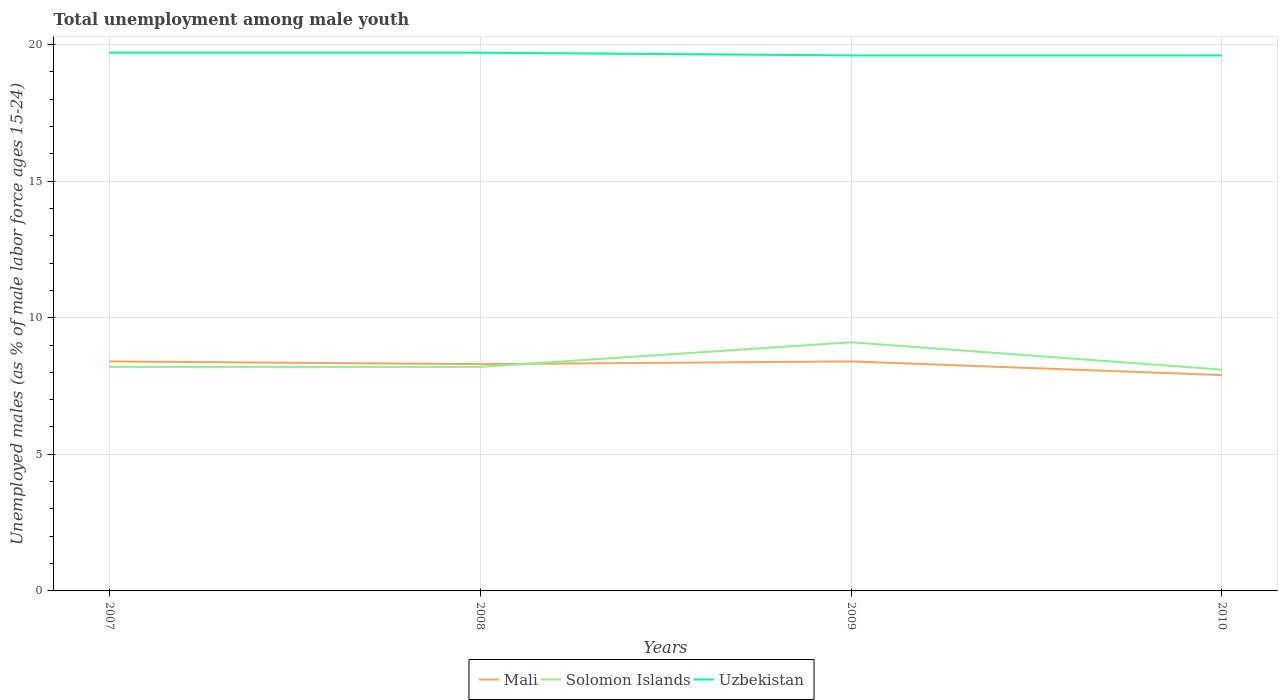Is the number of lines equal to the number of legend labels?
Give a very brief answer. Yes. Across all years, what is the maximum percentage of unemployed males in in Uzbekistan?
Ensure brevity in your answer.  19.6. What is the difference between the highest and the second highest percentage of unemployed males in in Mali?
Provide a short and direct response. 0.5. Is the percentage of unemployed males in in Uzbekistan strictly greater than the percentage of unemployed males in in Solomon Islands over the years?
Ensure brevity in your answer.  No. How many lines are there?
Offer a very short reply. 3. How many years are there in the graph?
Give a very brief answer. 4. Are the values on the major ticks of Y-axis written in scientific E-notation?
Offer a very short reply. No. Does the graph contain grids?
Your response must be concise. Yes. Where does the legend appear in the graph?
Keep it short and to the point. Bottom center. How many legend labels are there?
Provide a succinct answer. 3. What is the title of the graph?
Your answer should be compact. Total unemployment among male youth. What is the label or title of the Y-axis?
Offer a very short reply. Unemployed males (as % of male labor force ages 15-24). What is the Unemployed males (as % of male labor force ages 15-24) in Mali in 2007?
Provide a short and direct response. 8.4. What is the Unemployed males (as % of male labor force ages 15-24) in Solomon Islands in 2007?
Ensure brevity in your answer.  8.2. What is the Unemployed males (as % of male labor force ages 15-24) in Uzbekistan in 2007?
Provide a succinct answer. 19.7. What is the Unemployed males (as % of male labor force ages 15-24) of Mali in 2008?
Your response must be concise. 8.3. What is the Unemployed males (as % of male labor force ages 15-24) of Solomon Islands in 2008?
Your answer should be compact. 8.2. What is the Unemployed males (as % of male labor force ages 15-24) of Uzbekistan in 2008?
Provide a succinct answer. 19.7. What is the Unemployed males (as % of male labor force ages 15-24) in Mali in 2009?
Offer a very short reply. 8.4. What is the Unemployed males (as % of male labor force ages 15-24) in Solomon Islands in 2009?
Your answer should be compact. 9.1. What is the Unemployed males (as % of male labor force ages 15-24) of Uzbekistan in 2009?
Your answer should be compact. 19.6. What is the Unemployed males (as % of male labor force ages 15-24) in Mali in 2010?
Your answer should be very brief. 7.9. What is the Unemployed males (as % of male labor force ages 15-24) in Solomon Islands in 2010?
Ensure brevity in your answer.  8.1. What is the Unemployed males (as % of male labor force ages 15-24) in Uzbekistan in 2010?
Your answer should be very brief. 19.6. Across all years, what is the maximum Unemployed males (as % of male labor force ages 15-24) in Mali?
Your response must be concise. 8.4. Across all years, what is the maximum Unemployed males (as % of male labor force ages 15-24) of Solomon Islands?
Ensure brevity in your answer.  9.1. Across all years, what is the maximum Unemployed males (as % of male labor force ages 15-24) of Uzbekistan?
Your response must be concise. 19.7. Across all years, what is the minimum Unemployed males (as % of male labor force ages 15-24) of Mali?
Your answer should be compact. 7.9. Across all years, what is the minimum Unemployed males (as % of male labor force ages 15-24) of Solomon Islands?
Ensure brevity in your answer.  8.1. Across all years, what is the minimum Unemployed males (as % of male labor force ages 15-24) in Uzbekistan?
Make the answer very short. 19.6. What is the total Unemployed males (as % of male labor force ages 15-24) in Solomon Islands in the graph?
Ensure brevity in your answer.  33.6. What is the total Unemployed males (as % of male labor force ages 15-24) in Uzbekistan in the graph?
Offer a very short reply. 78.6. What is the difference between the Unemployed males (as % of male labor force ages 15-24) of Mali in 2007 and that in 2009?
Your response must be concise. 0. What is the difference between the Unemployed males (as % of male labor force ages 15-24) in Solomon Islands in 2007 and that in 2009?
Give a very brief answer. -0.9. What is the difference between the Unemployed males (as % of male labor force ages 15-24) in Uzbekistan in 2007 and that in 2009?
Give a very brief answer. 0.1. What is the difference between the Unemployed males (as % of male labor force ages 15-24) in Mali in 2008 and that in 2009?
Your answer should be compact. -0.1. What is the difference between the Unemployed males (as % of male labor force ages 15-24) in Mali in 2008 and that in 2010?
Your answer should be compact. 0.4. What is the difference between the Unemployed males (as % of male labor force ages 15-24) in Uzbekistan in 2008 and that in 2010?
Offer a very short reply. 0.1. What is the difference between the Unemployed males (as % of male labor force ages 15-24) of Mali in 2009 and that in 2010?
Give a very brief answer. 0.5. What is the difference between the Unemployed males (as % of male labor force ages 15-24) in Solomon Islands in 2009 and that in 2010?
Keep it short and to the point. 1. What is the difference between the Unemployed males (as % of male labor force ages 15-24) of Solomon Islands in 2007 and the Unemployed males (as % of male labor force ages 15-24) of Uzbekistan in 2008?
Give a very brief answer. -11.5. What is the difference between the Unemployed males (as % of male labor force ages 15-24) in Mali in 2007 and the Unemployed males (as % of male labor force ages 15-24) in Uzbekistan in 2009?
Your response must be concise. -11.2. What is the difference between the Unemployed males (as % of male labor force ages 15-24) in Solomon Islands in 2007 and the Unemployed males (as % of male labor force ages 15-24) in Uzbekistan in 2009?
Ensure brevity in your answer.  -11.4. What is the difference between the Unemployed males (as % of male labor force ages 15-24) in Mali in 2007 and the Unemployed males (as % of male labor force ages 15-24) in Solomon Islands in 2010?
Your answer should be very brief. 0.3. What is the difference between the Unemployed males (as % of male labor force ages 15-24) in Mali in 2008 and the Unemployed males (as % of male labor force ages 15-24) in Uzbekistan in 2009?
Offer a terse response. -11.3. What is the difference between the Unemployed males (as % of male labor force ages 15-24) in Mali in 2008 and the Unemployed males (as % of male labor force ages 15-24) in Solomon Islands in 2010?
Provide a short and direct response. 0.2. What is the difference between the Unemployed males (as % of male labor force ages 15-24) in Solomon Islands in 2008 and the Unemployed males (as % of male labor force ages 15-24) in Uzbekistan in 2010?
Your answer should be compact. -11.4. What is the difference between the Unemployed males (as % of male labor force ages 15-24) in Mali in 2009 and the Unemployed males (as % of male labor force ages 15-24) in Solomon Islands in 2010?
Provide a short and direct response. 0.3. What is the average Unemployed males (as % of male labor force ages 15-24) in Mali per year?
Give a very brief answer. 8.25. What is the average Unemployed males (as % of male labor force ages 15-24) of Uzbekistan per year?
Ensure brevity in your answer.  19.65. In the year 2008, what is the difference between the Unemployed males (as % of male labor force ages 15-24) in Mali and Unemployed males (as % of male labor force ages 15-24) in Solomon Islands?
Ensure brevity in your answer.  0.1. In the year 2008, what is the difference between the Unemployed males (as % of male labor force ages 15-24) in Mali and Unemployed males (as % of male labor force ages 15-24) in Uzbekistan?
Give a very brief answer. -11.4. In the year 2008, what is the difference between the Unemployed males (as % of male labor force ages 15-24) of Solomon Islands and Unemployed males (as % of male labor force ages 15-24) of Uzbekistan?
Your response must be concise. -11.5. In the year 2009, what is the difference between the Unemployed males (as % of male labor force ages 15-24) in Solomon Islands and Unemployed males (as % of male labor force ages 15-24) in Uzbekistan?
Keep it short and to the point. -10.5. In the year 2010, what is the difference between the Unemployed males (as % of male labor force ages 15-24) of Mali and Unemployed males (as % of male labor force ages 15-24) of Solomon Islands?
Your response must be concise. -0.2. In the year 2010, what is the difference between the Unemployed males (as % of male labor force ages 15-24) of Solomon Islands and Unemployed males (as % of male labor force ages 15-24) of Uzbekistan?
Keep it short and to the point. -11.5. What is the ratio of the Unemployed males (as % of male labor force ages 15-24) in Solomon Islands in 2007 to that in 2008?
Keep it short and to the point. 1. What is the ratio of the Unemployed males (as % of male labor force ages 15-24) of Mali in 2007 to that in 2009?
Provide a short and direct response. 1. What is the ratio of the Unemployed males (as % of male labor force ages 15-24) of Solomon Islands in 2007 to that in 2009?
Your answer should be very brief. 0.9. What is the ratio of the Unemployed males (as % of male labor force ages 15-24) of Mali in 2007 to that in 2010?
Provide a short and direct response. 1.06. What is the ratio of the Unemployed males (as % of male labor force ages 15-24) in Solomon Islands in 2007 to that in 2010?
Your answer should be compact. 1.01. What is the ratio of the Unemployed males (as % of male labor force ages 15-24) of Uzbekistan in 2007 to that in 2010?
Your answer should be compact. 1.01. What is the ratio of the Unemployed males (as % of male labor force ages 15-24) of Solomon Islands in 2008 to that in 2009?
Offer a very short reply. 0.9. What is the ratio of the Unemployed males (as % of male labor force ages 15-24) of Uzbekistan in 2008 to that in 2009?
Give a very brief answer. 1.01. What is the ratio of the Unemployed males (as % of male labor force ages 15-24) of Mali in 2008 to that in 2010?
Provide a short and direct response. 1.05. What is the ratio of the Unemployed males (as % of male labor force ages 15-24) of Solomon Islands in 2008 to that in 2010?
Make the answer very short. 1.01. What is the ratio of the Unemployed males (as % of male labor force ages 15-24) of Uzbekistan in 2008 to that in 2010?
Give a very brief answer. 1.01. What is the ratio of the Unemployed males (as % of male labor force ages 15-24) of Mali in 2009 to that in 2010?
Offer a terse response. 1.06. What is the ratio of the Unemployed males (as % of male labor force ages 15-24) in Solomon Islands in 2009 to that in 2010?
Give a very brief answer. 1.12. What is the ratio of the Unemployed males (as % of male labor force ages 15-24) in Uzbekistan in 2009 to that in 2010?
Your answer should be very brief. 1. What is the difference between the highest and the second highest Unemployed males (as % of male labor force ages 15-24) of Solomon Islands?
Make the answer very short. 0.9. What is the difference between the highest and the lowest Unemployed males (as % of male labor force ages 15-24) of Mali?
Your response must be concise. 0.5. What is the difference between the highest and the lowest Unemployed males (as % of male labor force ages 15-24) of Solomon Islands?
Provide a succinct answer. 1. What is the difference between the highest and the lowest Unemployed males (as % of male labor force ages 15-24) of Uzbekistan?
Keep it short and to the point. 0.1. 